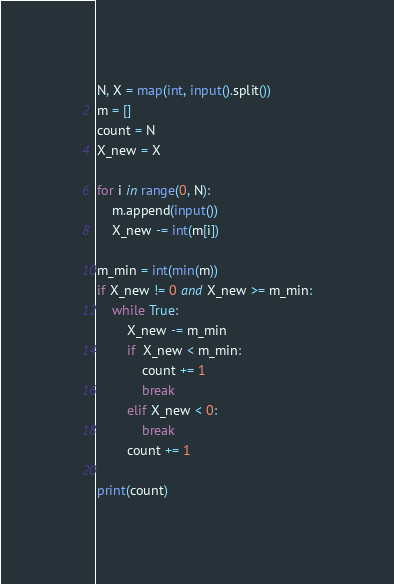Convert code to text. <code><loc_0><loc_0><loc_500><loc_500><_Python_>N, X = map(int, input().split())
m = []
count = N
X_new = X

for i in range(0, N):
	m.append(input())
	X_new -= int(m[i])

m_min = int(min(m))
if X_new != 0 and X_new >= m_min:
	while True:
		X_new -= m_min
		if  X_new < m_min:
			count += 1
			break
		elif X_new < 0:
			break
		count += 1

print(count)</code> 